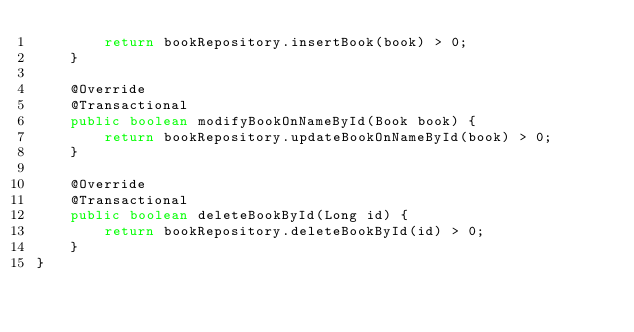Convert code to text. <code><loc_0><loc_0><loc_500><loc_500><_Java_>        return bookRepository.insertBook(book) > 0;
    }

    @Override
    @Transactional
    public boolean modifyBookOnNameById(Book book) {
        return bookRepository.updateBookOnNameById(book) > 0;
    }

    @Override
    @Transactional
    public boolean deleteBookById(Long id) {
        return bookRepository.deleteBookById(id) > 0;
    }
}
</code> 